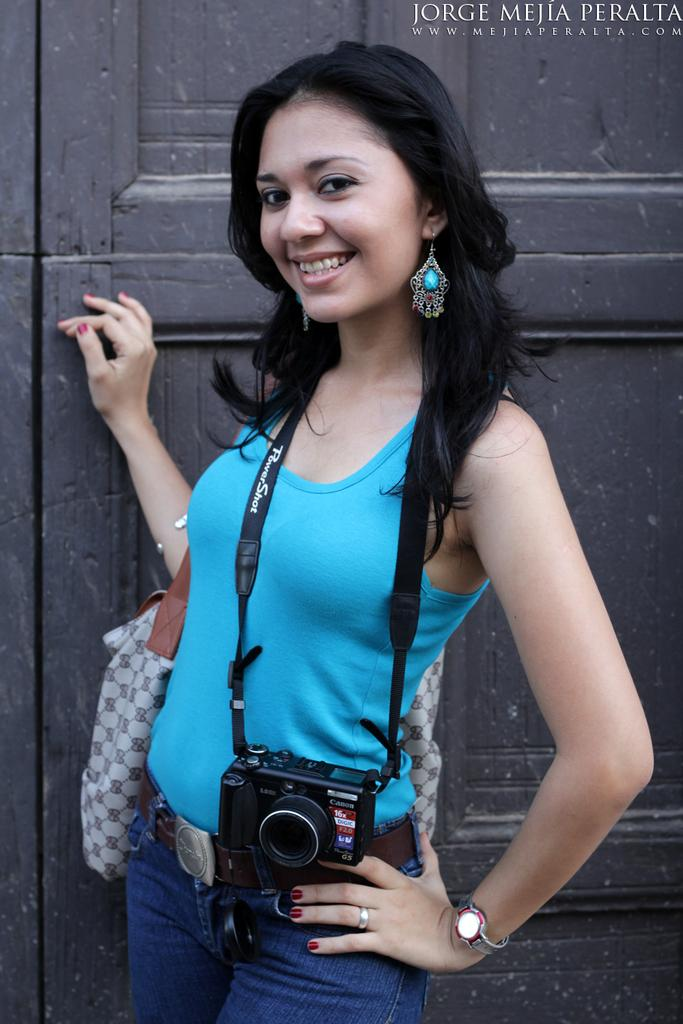Who is the main subject in the image? There is a girl in the image. What is the girl wearing? The girl is wearing a dress. What is the girl holding in the image? The girl is holding a camera. What expression does the girl have? The girl is smiling. What can be seen in the top right-hand side of the image? There is text in the top right-hand side of the image. What type of doll can be seen skating in the church in the image? There is no doll or skating activity present in the image. The image features a girl holding a camera and smiling, with text in the top right-hand side. 